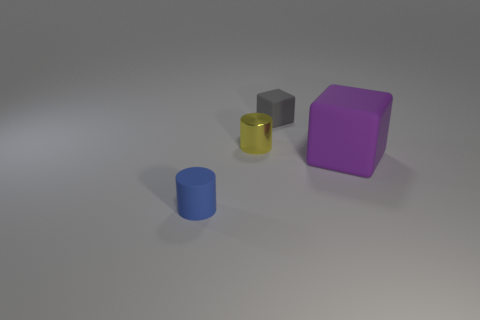Add 1 gray matte objects. How many objects exist? 5 Subtract 0 green balls. How many objects are left? 4 Subtract all green cubes. Subtract all cylinders. How many objects are left? 2 Add 2 tiny gray cubes. How many tiny gray cubes are left? 3 Add 2 gray matte things. How many gray matte things exist? 3 